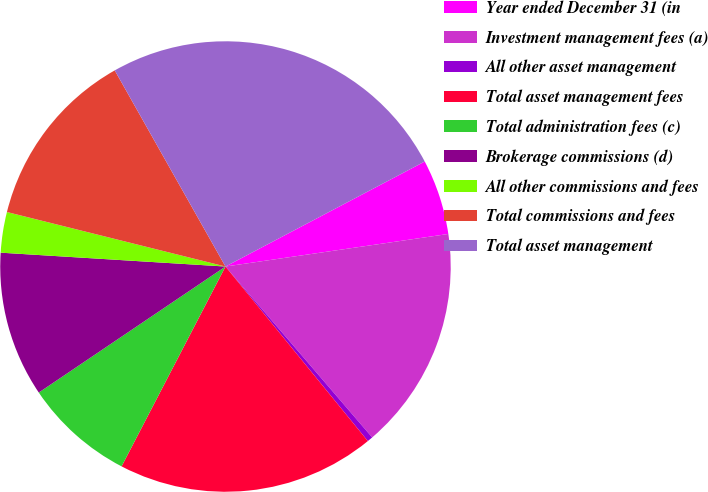Convert chart to OTSL. <chart><loc_0><loc_0><loc_500><loc_500><pie_chart><fcel>Year ended December 31 (in<fcel>Investment management fees (a)<fcel>All other asset management<fcel>Total asset management fees<fcel>Total administration fees (c)<fcel>Brokerage commissions (d)<fcel>All other commissions and fees<fcel>Total commissions and fees<fcel>Total asset management<nl><fcel>5.41%<fcel>16.02%<fcel>0.4%<fcel>18.52%<fcel>7.92%<fcel>10.43%<fcel>2.91%<fcel>12.93%<fcel>25.46%<nl></chart> 